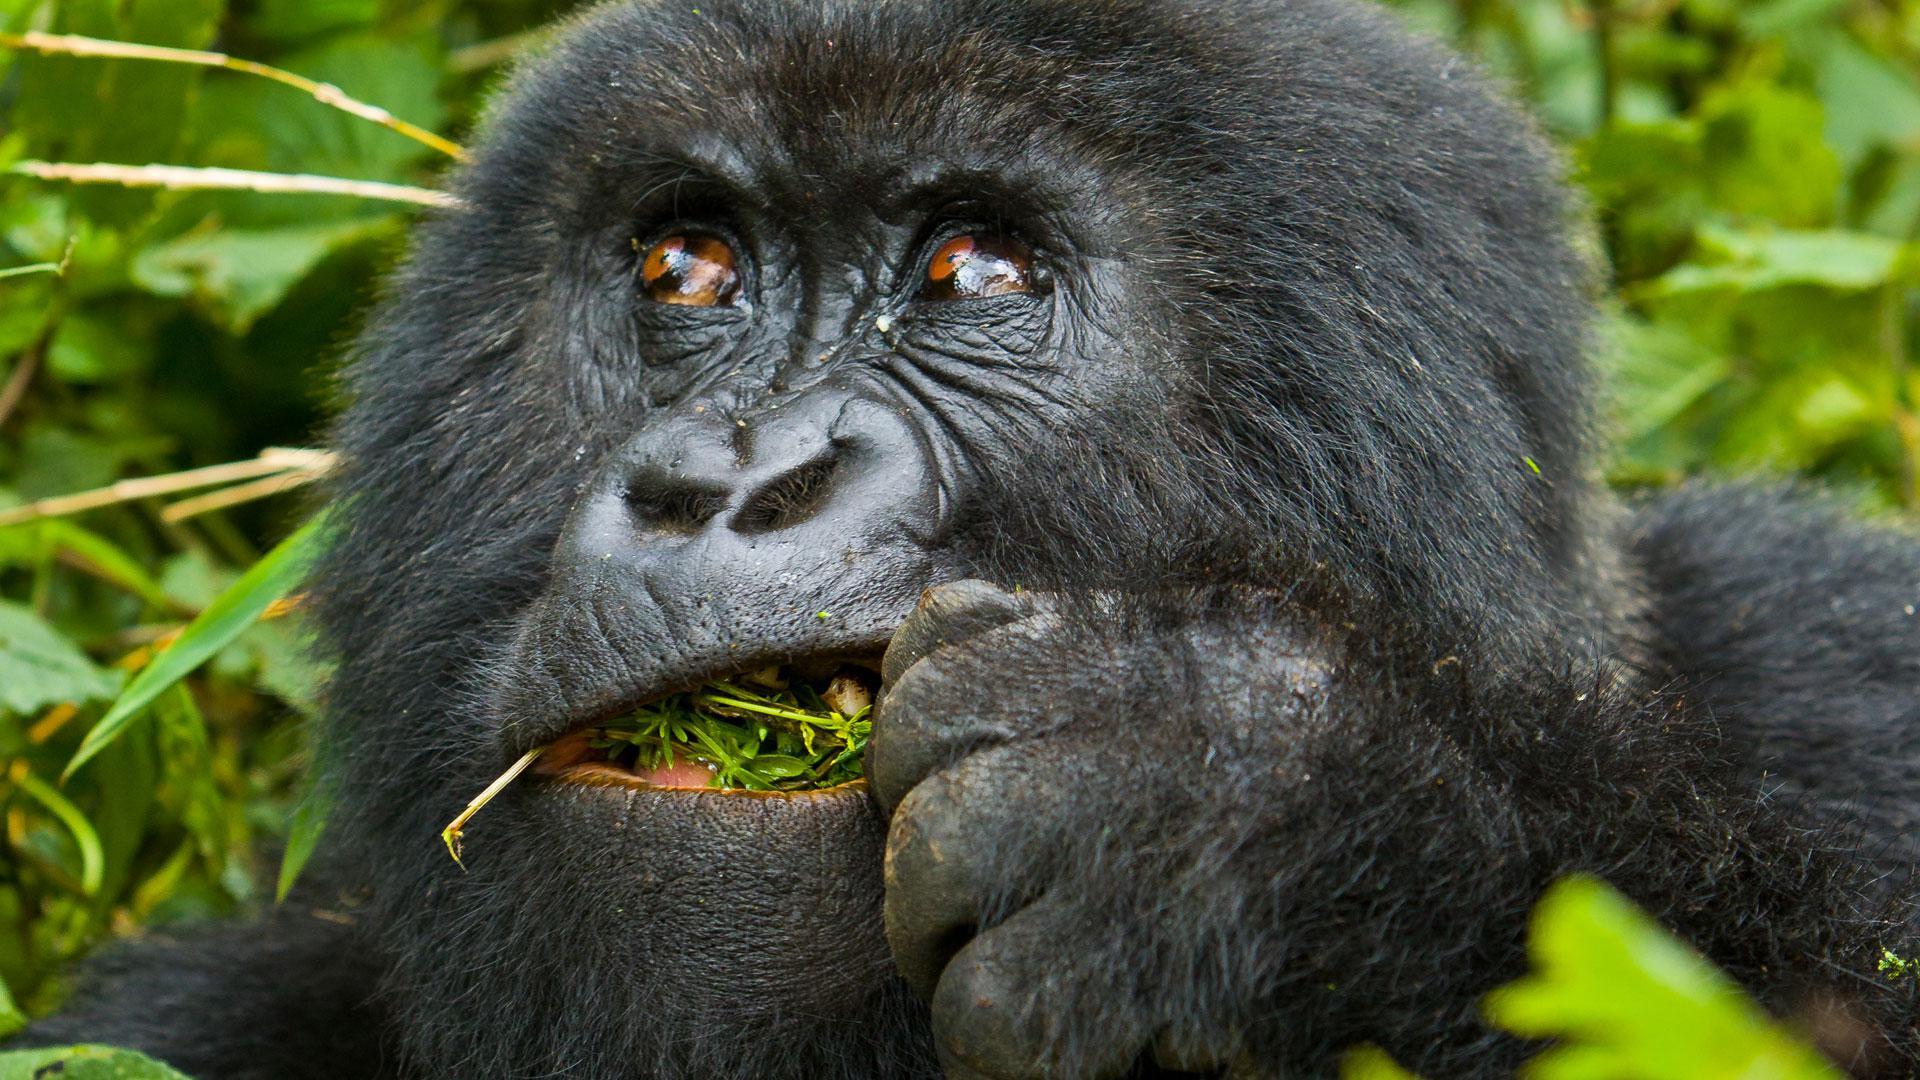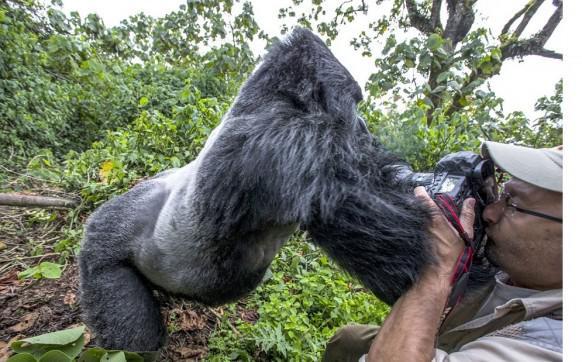The first image is the image on the left, the second image is the image on the right. Analyze the images presented: Is the assertion "The right image contains no more than three gorillas and includes a furry young gorilla, and the left image shows a close family group of gorillas facing forward." valid? Answer yes or no. No. The first image is the image on the left, the second image is the image on the right. For the images displayed, is the sentence "There are no more than six gorillas in total." factually correct? Answer yes or no. Yes. 